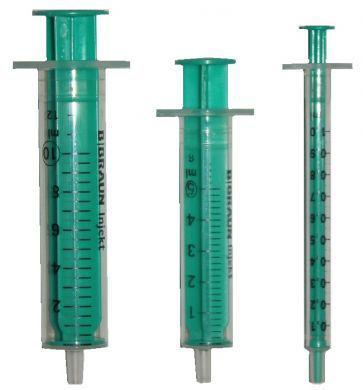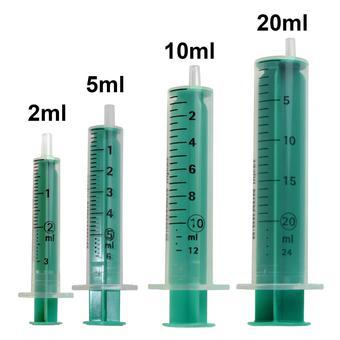The first image is the image on the left, the second image is the image on the right. For the images displayed, is the sentence "Right and left images contain the same number of syringe-type items." factually correct? Answer yes or no. No. The first image is the image on the left, the second image is the image on the right. Considering the images on both sides, is "There are the same amount of syringes in the image on the left as in the image on the right." valid? Answer yes or no. No. 